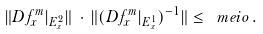Convert formula to latex. <formula><loc_0><loc_0><loc_500><loc_500>\| D f ^ { m } _ { x } | _ { E ^ { 2 } _ { x } } \| \, \cdot \, \| ( D f ^ { m } _ { x } | _ { E ^ { 1 } _ { x } } ) ^ { - 1 } \| \leq \ m e i o \, .</formula> 